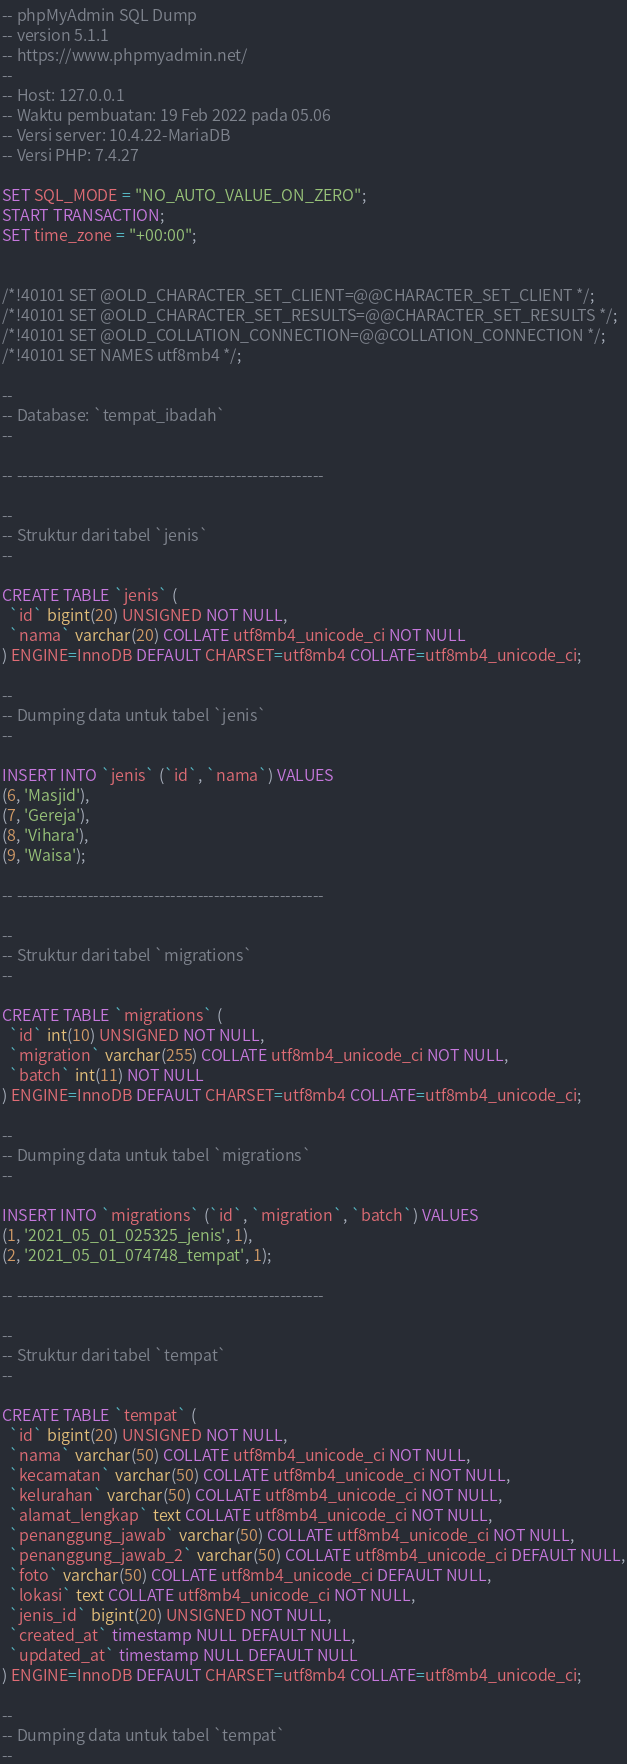Convert code to text. <code><loc_0><loc_0><loc_500><loc_500><_SQL_>-- phpMyAdmin SQL Dump
-- version 5.1.1
-- https://www.phpmyadmin.net/
--
-- Host: 127.0.0.1
-- Waktu pembuatan: 19 Feb 2022 pada 05.06
-- Versi server: 10.4.22-MariaDB
-- Versi PHP: 7.4.27

SET SQL_MODE = "NO_AUTO_VALUE_ON_ZERO";
START TRANSACTION;
SET time_zone = "+00:00";


/*!40101 SET @OLD_CHARACTER_SET_CLIENT=@@CHARACTER_SET_CLIENT */;
/*!40101 SET @OLD_CHARACTER_SET_RESULTS=@@CHARACTER_SET_RESULTS */;
/*!40101 SET @OLD_COLLATION_CONNECTION=@@COLLATION_CONNECTION */;
/*!40101 SET NAMES utf8mb4 */;

--
-- Database: `tempat_ibadah`
--

-- --------------------------------------------------------

--
-- Struktur dari tabel `jenis`
--

CREATE TABLE `jenis` (
  `id` bigint(20) UNSIGNED NOT NULL,
  `nama` varchar(20) COLLATE utf8mb4_unicode_ci NOT NULL
) ENGINE=InnoDB DEFAULT CHARSET=utf8mb4 COLLATE=utf8mb4_unicode_ci;

--
-- Dumping data untuk tabel `jenis`
--

INSERT INTO `jenis` (`id`, `nama`) VALUES
(6, 'Masjid'),
(7, 'Gereja'),
(8, 'Vihara'),
(9, 'Waisa');

-- --------------------------------------------------------

--
-- Struktur dari tabel `migrations`
--

CREATE TABLE `migrations` (
  `id` int(10) UNSIGNED NOT NULL,
  `migration` varchar(255) COLLATE utf8mb4_unicode_ci NOT NULL,
  `batch` int(11) NOT NULL
) ENGINE=InnoDB DEFAULT CHARSET=utf8mb4 COLLATE=utf8mb4_unicode_ci;

--
-- Dumping data untuk tabel `migrations`
--

INSERT INTO `migrations` (`id`, `migration`, `batch`) VALUES
(1, '2021_05_01_025325_jenis', 1),
(2, '2021_05_01_074748_tempat', 1);

-- --------------------------------------------------------

--
-- Struktur dari tabel `tempat`
--

CREATE TABLE `tempat` (
  `id` bigint(20) UNSIGNED NOT NULL,
  `nama` varchar(50) COLLATE utf8mb4_unicode_ci NOT NULL,
  `kecamatan` varchar(50) COLLATE utf8mb4_unicode_ci NOT NULL,
  `kelurahan` varchar(50) COLLATE utf8mb4_unicode_ci NOT NULL,
  `alamat_lengkap` text COLLATE utf8mb4_unicode_ci NOT NULL,
  `penanggung_jawab` varchar(50) COLLATE utf8mb4_unicode_ci NOT NULL,
  `penanggung_jawab_2` varchar(50) COLLATE utf8mb4_unicode_ci DEFAULT NULL,
  `foto` varchar(50) COLLATE utf8mb4_unicode_ci DEFAULT NULL,
  `lokasi` text COLLATE utf8mb4_unicode_ci NOT NULL,
  `jenis_id` bigint(20) UNSIGNED NOT NULL,
  `created_at` timestamp NULL DEFAULT NULL,
  `updated_at` timestamp NULL DEFAULT NULL
) ENGINE=InnoDB DEFAULT CHARSET=utf8mb4 COLLATE=utf8mb4_unicode_ci;

--
-- Dumping data untuk tabel `tempat`
--
</code> 